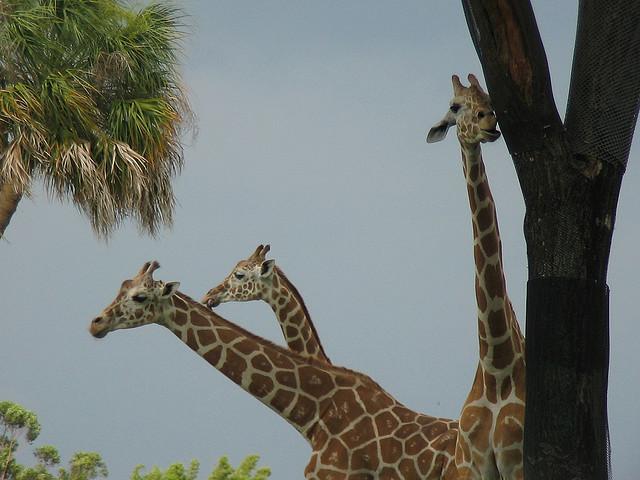How many animals are shown?
Write a very short answer. 3. Which giraffe is taller?
Quick response, please. Right. Why giraffes stick together?
Quick response, please. Family. What is above the giraffe?
Short answer required. Tree. Is the sun shining?
Short answer required. Yes. Is it a cloudy day?
Be succinct. No. What is the animal in the foreground?
Concise answer only. Giraffe. What is the giraffe trying to do?
Answer briefly. Eat. Are the giraffes brothers and sisters?
Quick response, please. Yes. Is there grass?
Answer briefly. No. How many animals?
Keep it brief. 3. Is this a male or a female giraffe?
Write a very short answer. Male. 